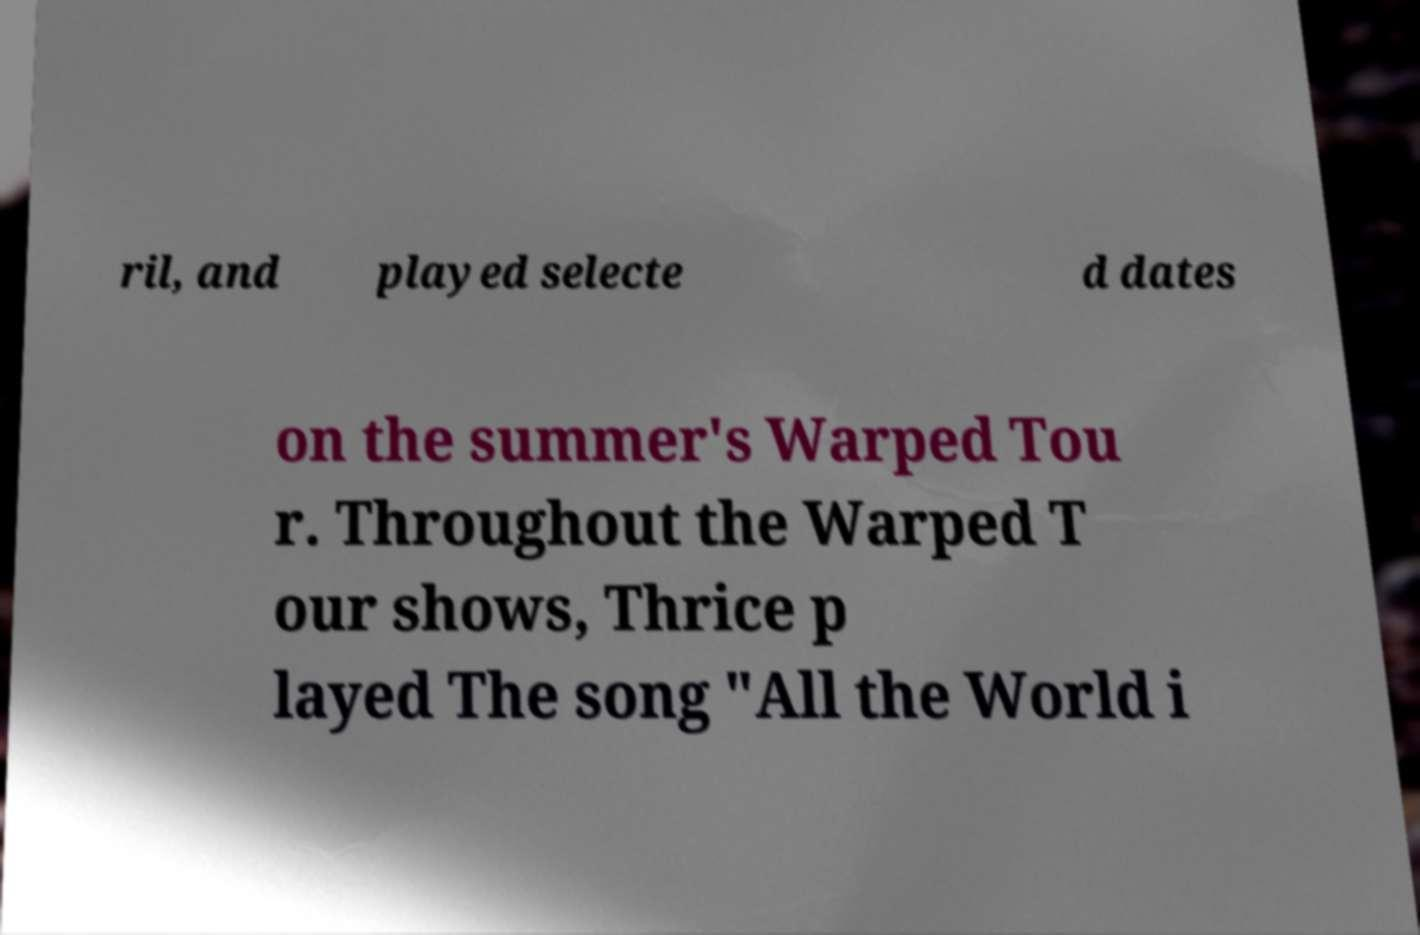For documentation purposes, I need the text within this image transcribed. Could you provide that? ril, and played selecte d dates on the summer's Warped Tou r. Throughout the Warped T our shows, Thrice p layed The song "All the World i 